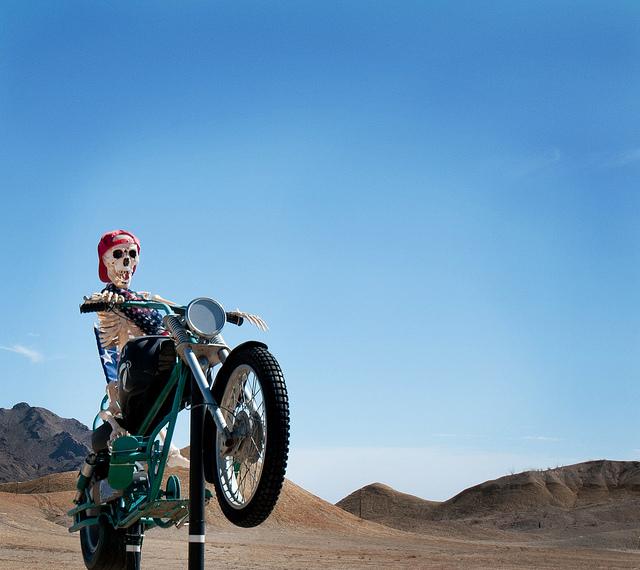How many motorcycles are there?
Write a very short answer. 1. Is there anything strange about the figure riding the bicycle?
Be succinct. Yes. What country flag is the rider wearing?
Concise answer only. Usa. What is on the rider's head?
Give a very brief answer. Cap. 